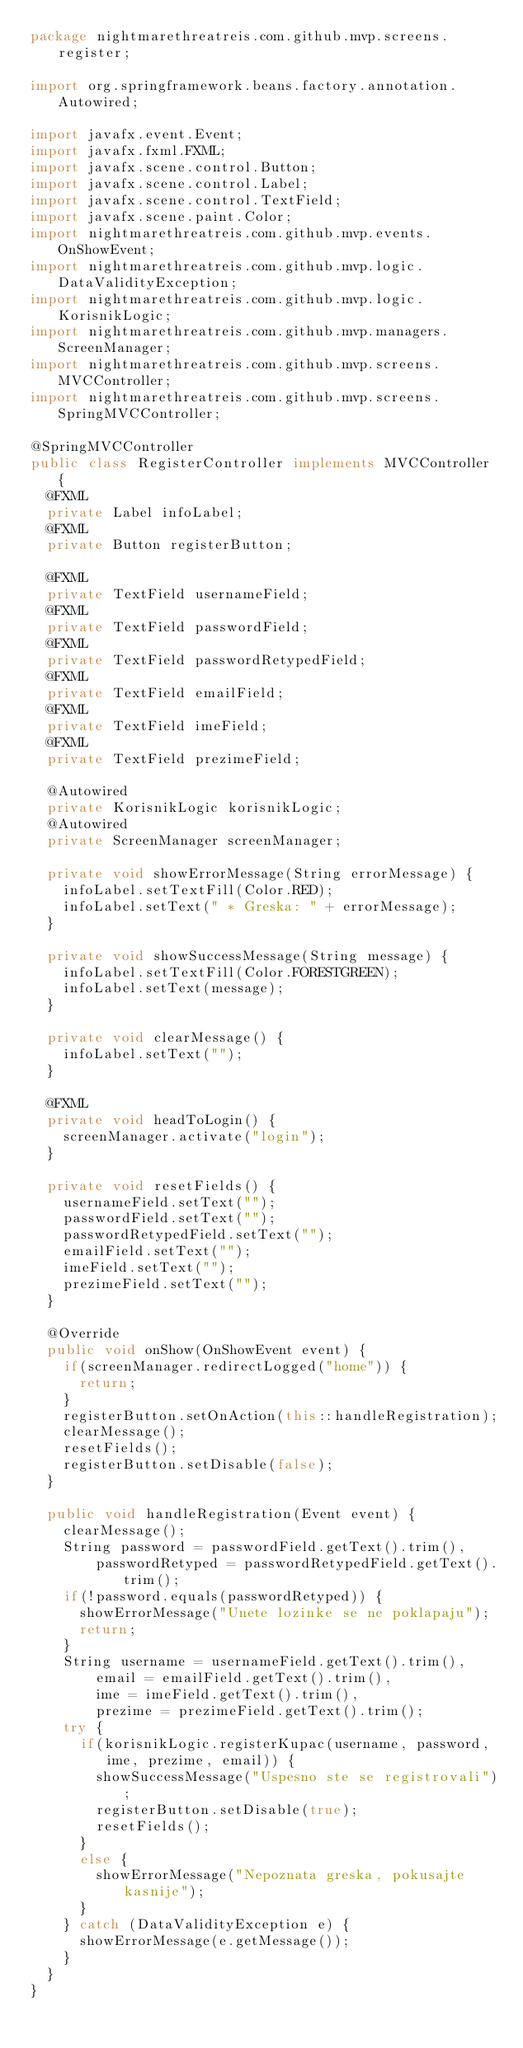Convert code to text. <code><loc_0><loc_0><loc_500><loc_500><_Java_>package nightmarethreatreis.com.github.mvp.screens.register;

import org.springframework.beans.factory.annotation.Autowired;

import javafx.event.Event;
import javafx.fxml.FXML;
import javafx.scene.control.Button;
import javafx.scene.control.Label;
import javafx.scene.control.TextField;
import javafx.scene.paint.Color;
import nightmarethreatreis.com.github.mvp.events.OnShowEvent;
import nightmarethreatreis.com.github.mvp.logic.DataValidityException;
import nightmarethreatreis.com.github.mvp.logic.KorisnikLogic;
import nightmarethreatreis.com.github.mvp.managers.ScreenManager;
import nightmarethreatreis.com.github.mvp.screens.MVCController;
import nightmarethreatreis.com.github.mvp.screens.SpringMVCController;

@SpringMVCController
public class RegisterController implements MVCController {
	@FXML
	private Label infoLabel;
	@FXML
	private Button registerButton;
	
	@FXML
	private TextField usernameField;
	@FXML
	private TextField passwordField;
	@FXML
	private TextField passwordRetypedField;
	@FXML
	private TextField emailField;
	@FXML
	private TextField imeField;
	@FXML
	private TextField prezimeField;
	
	@Autowired
	private KorisnikLogic korisnikLogic;
	@Autowired
	private ScreenManager screenManager;
	
	private void showErrorMessage(String errorMessage) {
		infoLabel.setTextFill(Color.RED);
		infoLabel.setText(" * Greska: " + errorMessage);
	}
	
	private void showSuccessMessage(String message) {
		infoLabel.setTextFill(Color.FORESTGREEN);
		infoLabel.setText(message);
	}
	
	private void clearMessage() {
		infoLabel.setText("");
	}
	
	@FXML
	private void headToLogin() {
		screenManager.activate("login");
	}
	
	private void resetFields() {
		usernameField.setText("");
		passwordField.setText("");
		passwordRetypedField.setText("");
		emailField.setText("");
		imeField.setText("");
		prezimeField.setText("");
	}
	
	@Override
	public void onShow(OnShowEvent event) {
		if(screenManager.redirectLogged("home")) {
			return;
		}
		registerButton.setOnAction(this::handleRegistration);
		clearMessage();
		resetFields();
		registerButton.setDisable(false);
	}
	
	public void handleRegistration(Event event) {
		clearMessage();
		String password = passwordField.getText().trim(), 
				passwordRetyped = passwordRetypedField.getText().trim();
		if(!password.equals(passwordRetyped)) {
			showErrorMessage("Unete lozinke se ne poklapaju");
			return;
		}
		String username = usernameField.getText().trim(),
				email = emailField.getText().trim(),
				ime = imeField.getText().trim(),
				prezime = prezimeField.getText().trim();
		try {
			if(korisnikLogic.registerKupac(username, password, ime, prezime, email)) {
				showSuccessMessage("Uspesno ste se registrovali");
				registerButton.setDisable(true);
				resetFields();
			}
			else {
				showErrorMessage("Nepoznata greska, pokusajte kasnije");
			}
		} catch (DataValidityException e) {
			showErrorMessage(e.getMessage());
		}
	}
}
</code> 